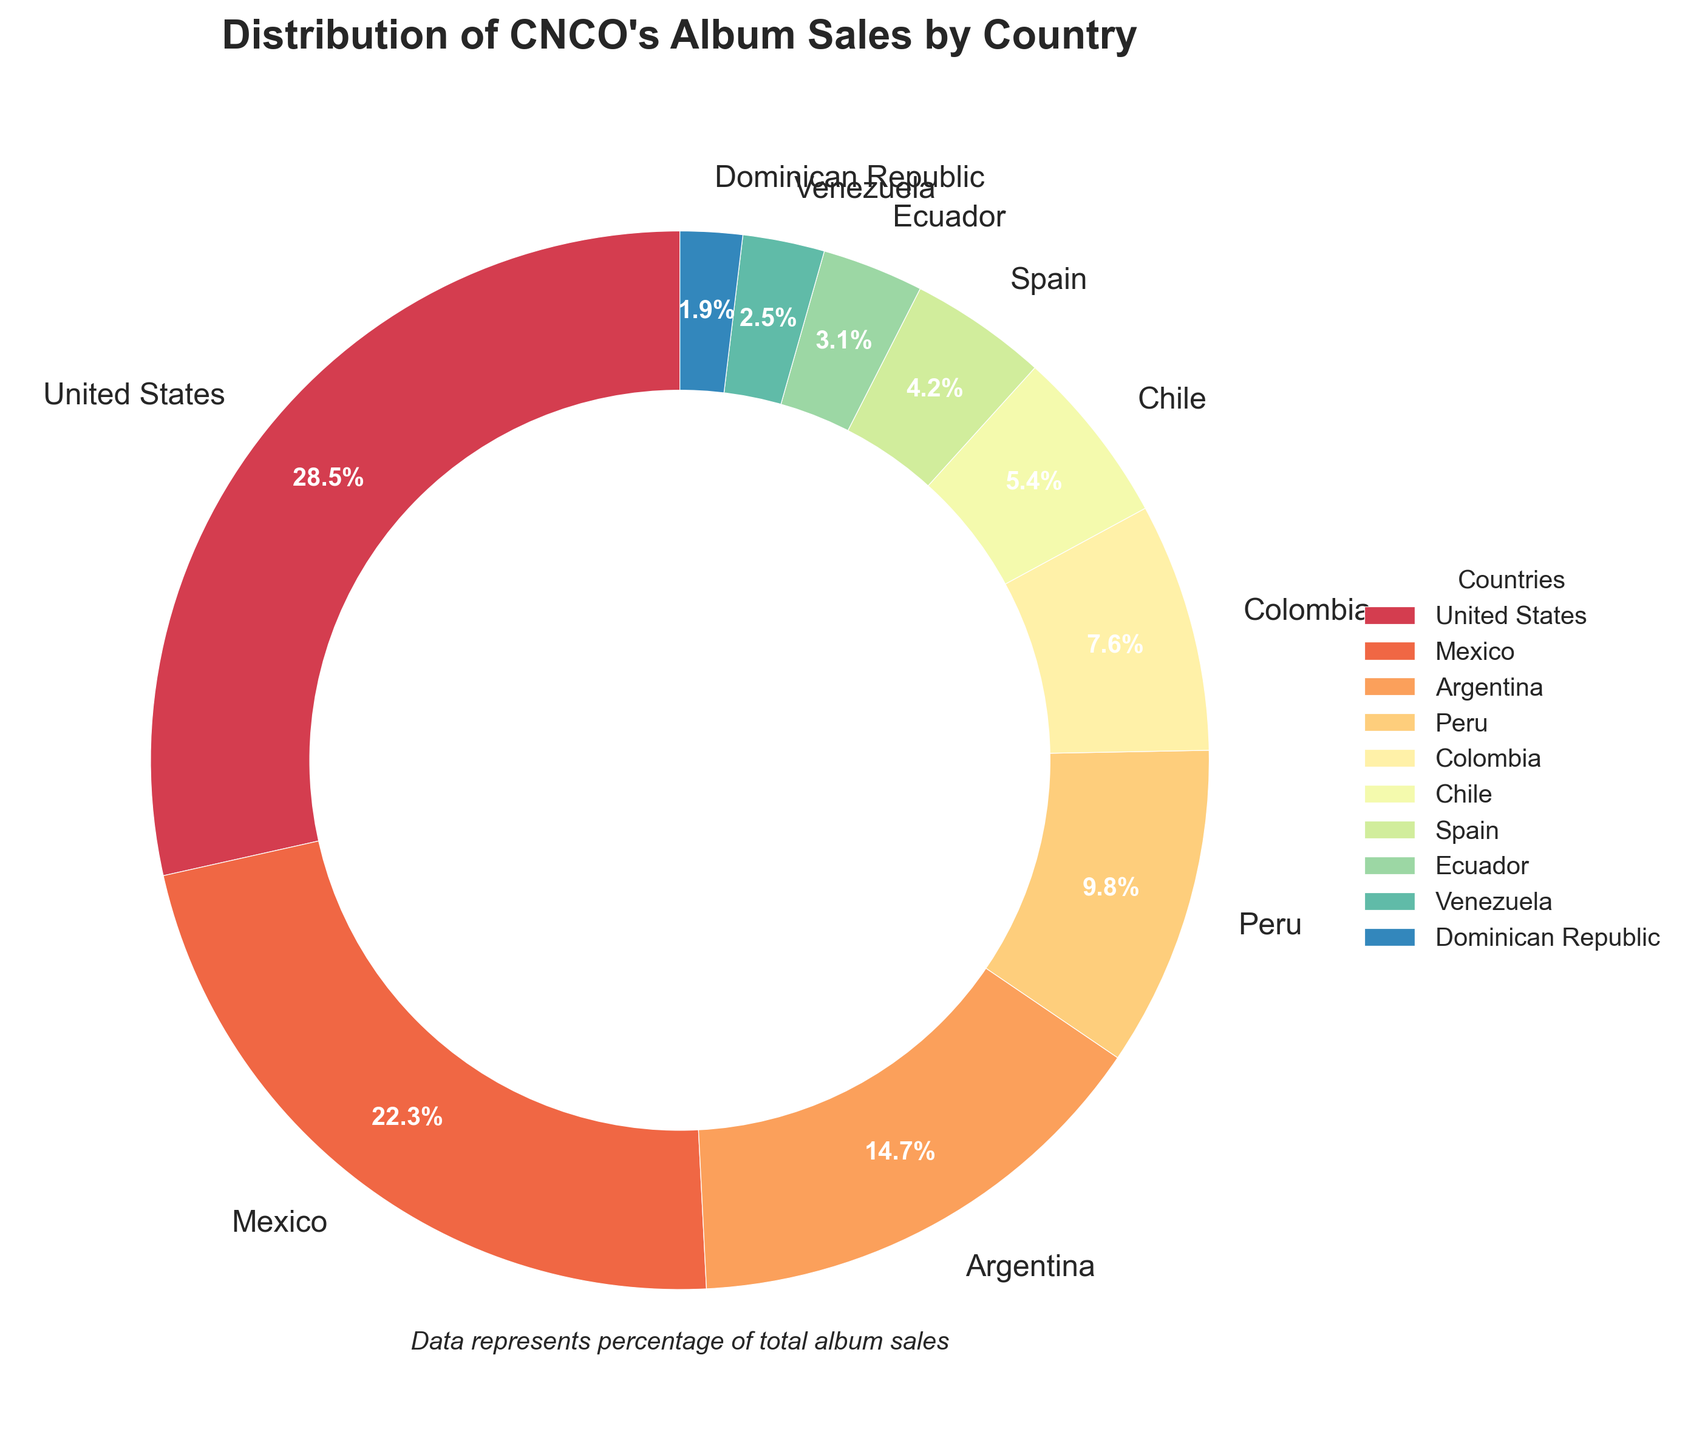Which country has the highest percentage of album sales? The country with the highest percentage is the one with the largest section in the pie chart and is labeled with the highest percentage. In this case, it's the United States with 28.5%.
Answer: United States Which three countries have the lowest album sales percentages? Identifying the three smallest segments of the pie chart, we find that Venezuela (2.5%), Ecuador (3.1%), and the Dominican Republic (1.9%) have the lowest album sales percentages.
Answer: Ecuador, Venezuela, Dominican Republic What is the combined album sales percentage for Mexico and Argentina? Add the percentages for Mexico (22.3%) and Argentina (14.7%): 22.3 + 14.7 = 37.0%.
Answer: 37.0% How much larger is the album sales percentage in the United States compared to Colombia? Subtract the percentage of Colombia (7.6%) from that of the United States (28.5%): 28.5 - 7.6 = 20.9%.
Answer: 20.9% Which country has a higher album sales percentage, Chile or Spain? Compare the percentages for Chile (5.4%) and Spain (4.2%): Chile has a higher percentage than Spain.
Answer: Chile What is the total album sales percentage for countries in South America listed in the chart? Sum the percentages for Argentina (14.7%), Peru (9.8%), Colombia (7.6%), Chile (5.4%), Ecuador (3.1%), and Venezuela (2.5%): 14.7 + 9.8 + 7.6 + 5.4 + 3.1 + 2.5 = 43.1%.
Answer: 43.1% Which visual attributes indicate the country with the smallest album sales percentage? The country with the smallest percentage is represented by the smallest wedge in the pie chart and has the percentage label of 1.9%. This corresponds to the Dominican Republic.
Answer: Dominican Republic What is the difference in album sales percentage between the top two countries? Subtract the percentage of Mexico (22.3%) from that of the United States (28.5%): 28.5% - 22.3% = 6.2%.
Answer: 6.2% Which regions contribute most significantly to CNCO's album sales based on the chart? The regions of North America (United States and Mexico) and South America (Argentina, Peru, Colombia, Chile, Ecuador, Venezuela) contribute significantly, with North America having 28.5% and 22.3%, and South America having a combined 43.1%.
Answer: North America, South America 